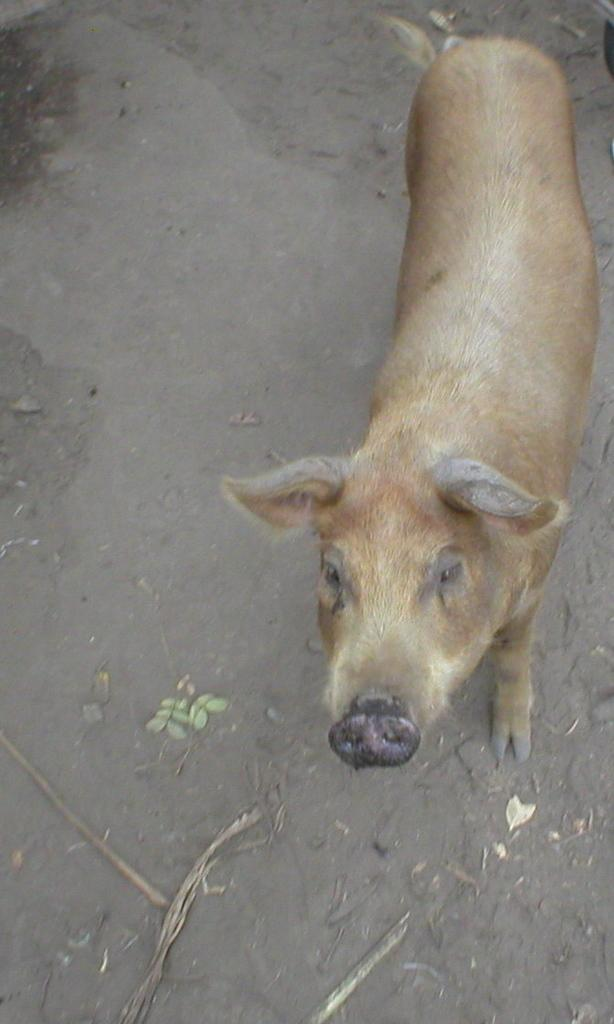What animal is present in the image? There is a pig in the image. What type of surface is at the bottom of the image? There is soil at the bottom of the image. What type of teeth can be seen in the image? There are no teeth visible in the image, as it features a pig and soil. 